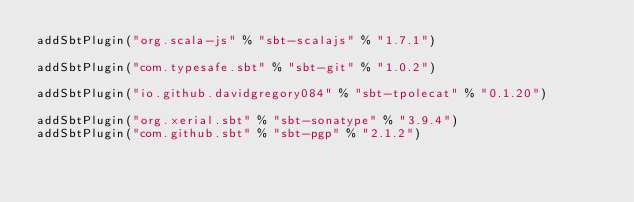Convert code to text. <code><loc_0><loc_0><loc_500><loc_500><_Scala_>addSbtPlugin("org.scala-js" % "sbt-scalajs" % "1.7.1")

addSbtPlugin("com.typesafe.sbt" % "sbt-git" % "1.0.2")

addSbtPlugin("io.github.davidgregory084" % "sbt-tpolecat" % "0.1.20")

addSbtPlugin("org.xerial.sbt" % "sbt-sonatype" % "3.9.4")
addSbtPlugin("com.github.sbt" % "sbt-pgp" % "2.1.2")
</code> 